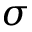<formula> <loc_0><loc_0><loc_500><loc_500>\sigma</formula> 